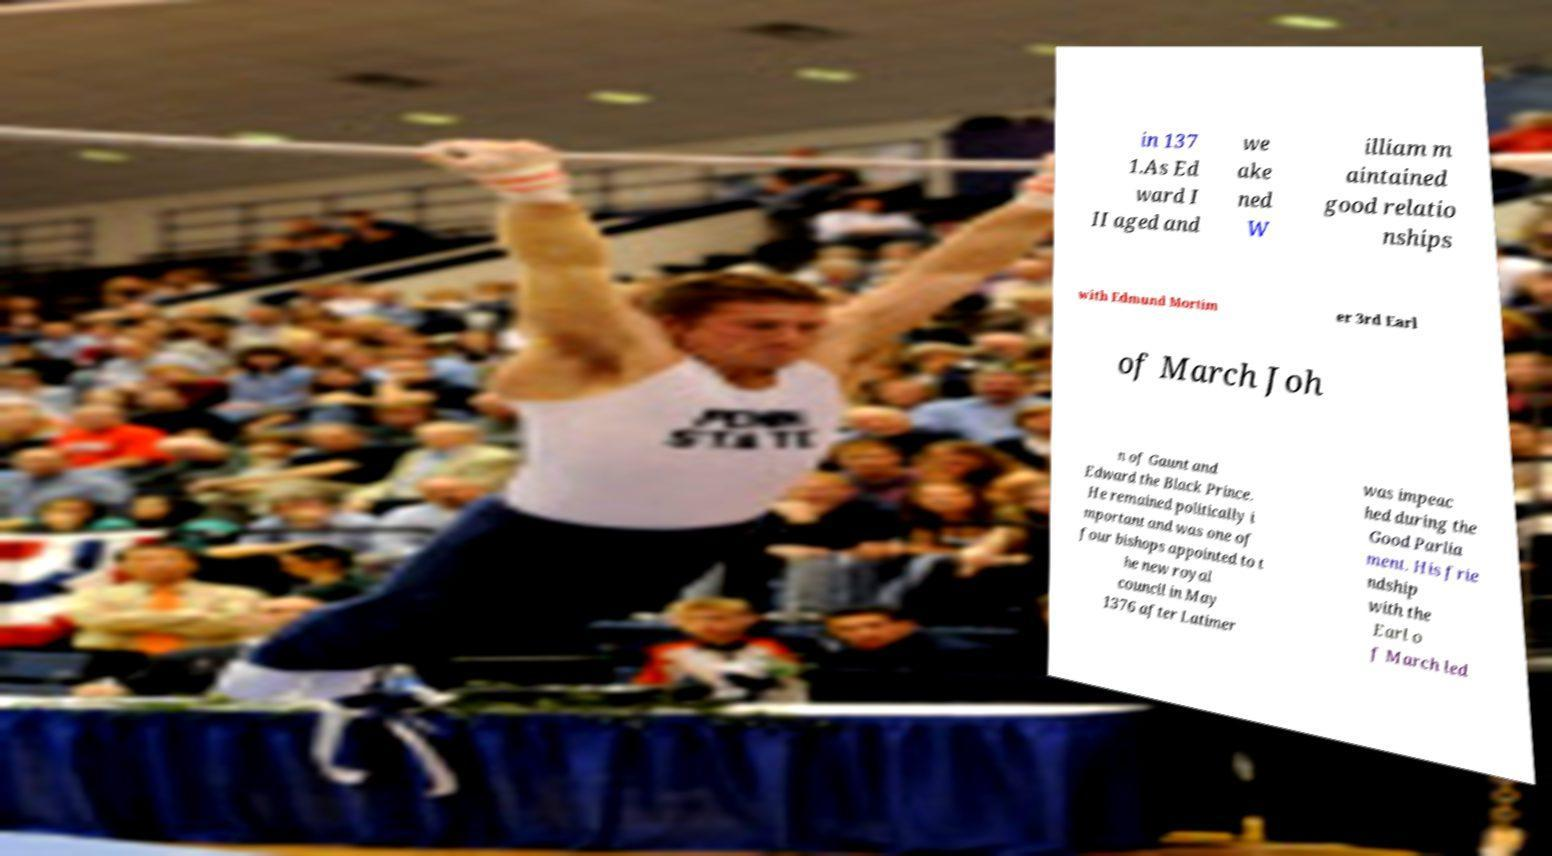Please identify and transcribe the text found in this image. in 137 1.As Ed ward I II aged and we ake ned W illiam m aintained good relatio nships with Edmund Mortim er 3rd Earl of March Joh n of Gaunt and Edward the Black Prince. He remained politically i mportant and was one of four bishops appointed to t he new royal council in May 1376 after Latimer was impeac hed during the Good Parlia ment. His frie ndship with the Earl o f March led 